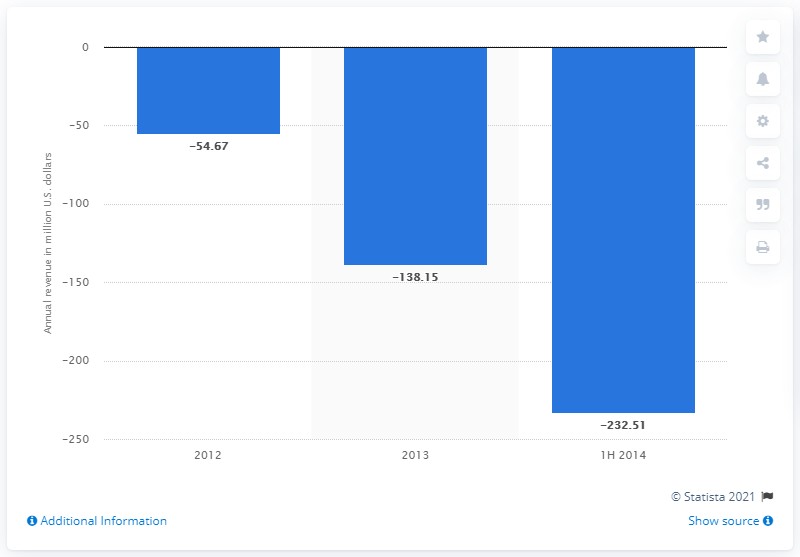Mention a couple of crucial points in this snapshot. In 2012, WhatsApp lost revenue. 